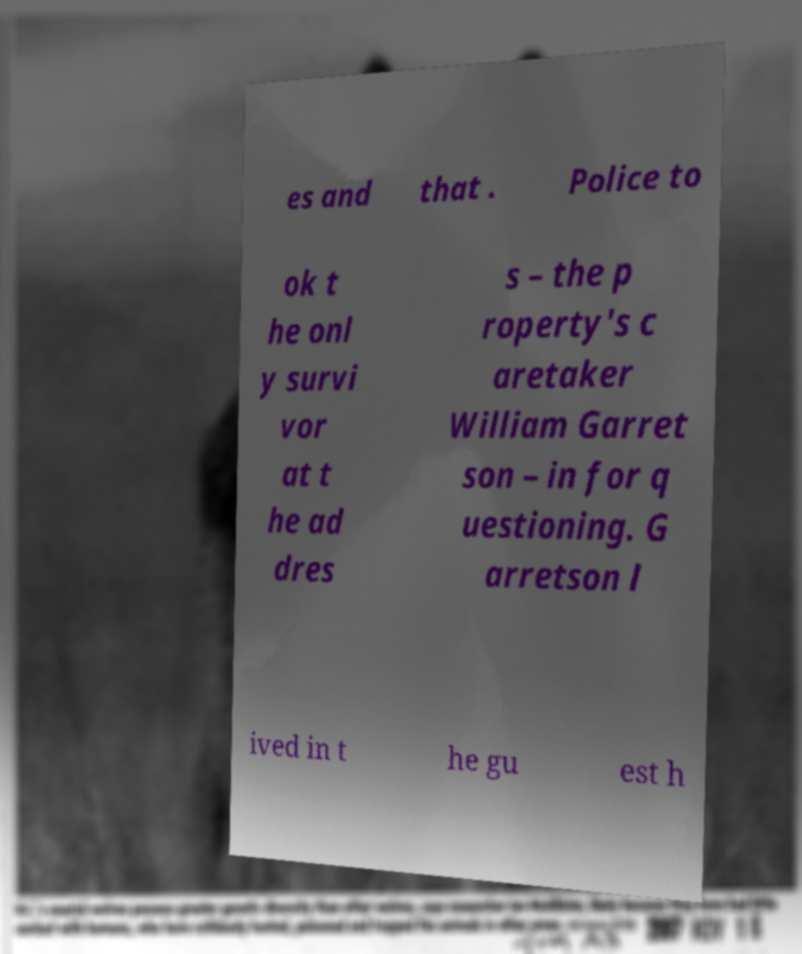There's text embedded in this image that I need extracted. Can you transcribe it verbatim? es and that . Police to ok t he onl y survi vor at t he ad dres s – the p roperty's c aretaker William Garret son – in for q uestioning. G arretson l ived in t he gu est h 